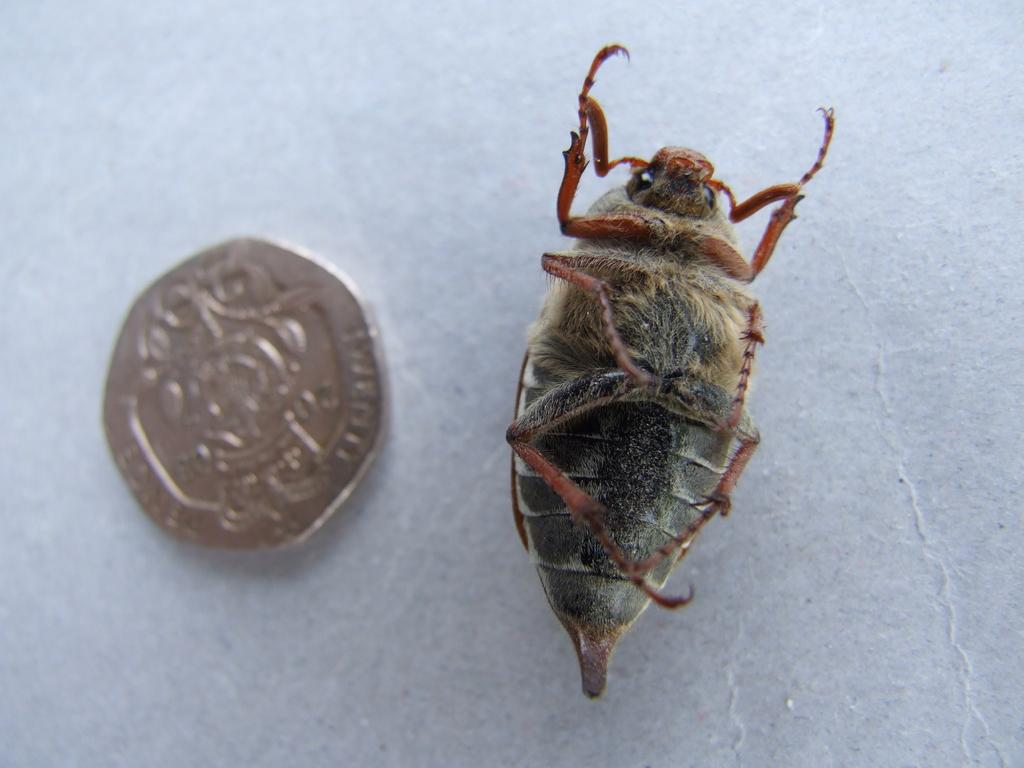What type of creature is present in the image? There is an insect in the image. What colors can be seen on the insect? The insect has black and brown colors. What other object is present in the image? There is a coin in the image. What is the background or surface on which the insect and coin are placed? The insect and coin are on a white surface. What type of treatment is the insect receiving in the image? There is no indication in the image that the insect is receiving any treatment. 